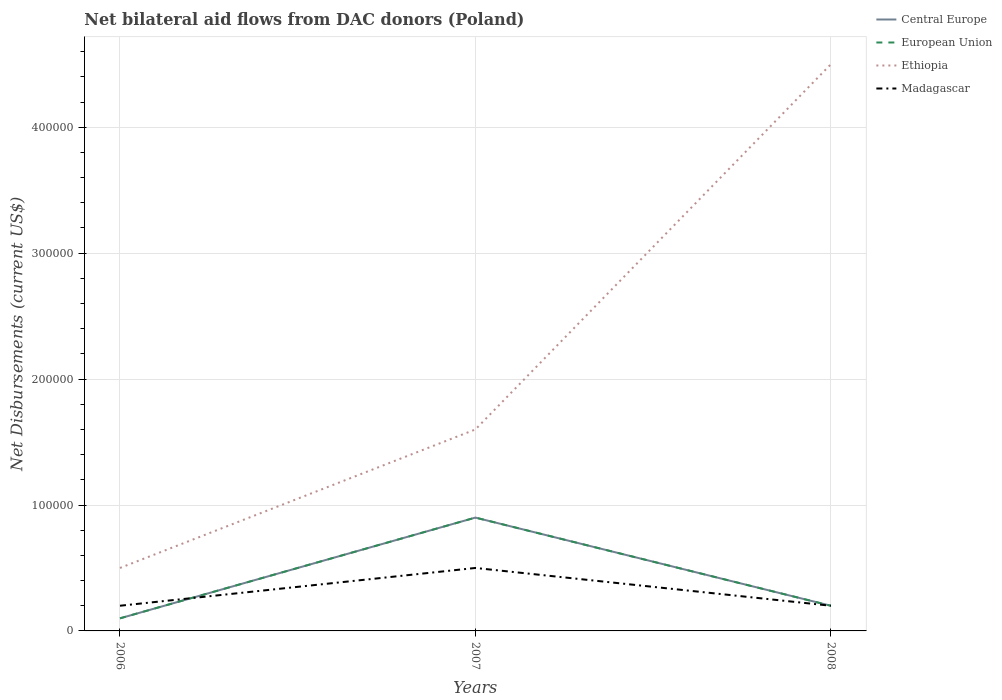How many different coloured lines are there?
Offer a very short reply. 4. Does the line corresponding to Madagascar intersect with the line corresponding to European Union?
Provide a short and direct response. Yes. Is the number of lines equal to the number of legend labels?
Your answer should be very brief. Yes. In which year was the net bilateral aid flows in European Union maximum?
Give a very brief answer. 2006. What is the total net bilateral aid flows in European Union in the graph?
Make the answer very short. -10000. What is the difference between the highest and the second highest net bilateral aid flows in Ethiopia?
Offer a terse response. 4.00e+05. What is the difference between the highest and the lowest net bilateral aid flows in Central Europe?
Offer a terse response. 1. Are the values on the major ticks of Y-axis written in scientific E-notation?
Provide a succinct answer. No. Where does the legend appear in the graph?
Ensure brevity in your answer.  Top right. How many legend labels are there?
Provide a short and direct response. 4. How are the legend labels stacked?
Your response must be concise. Vertical. What is the title of the graph?
Provide a succinct answer. Net bilateral aid flows from DAC donors (Poland). Does "Bermuda" appear as one of the legend labels in the graph?
Your answer should be compact. No. What is the label or title of the X-axis?
Your answer should be compact. Years. What is the label or title of the Y-axis?
Your answer should be very brief. Net Disbursements (current US$). What is the Net Disbursements (current US$) in European Union in 2006?
Offer a very short reply. 10000. What is the Net Disbursements (current US$) in Ethiopia in 2006?
Offer a terse response. 5.00e+04. What is the Net Disbursements (current US$) of Madagascar in 2006?
Offer a terse response. 2.00e+04. What is the Net Disbursements (current US$) in Central Europe in 2007?
Your response must be concise. 9.00e+04. What is the Net Disbursements (current US$) of Ethiopia in 2008?
Offer a terse response. 4.50e+05. What is the Net Disbursements (current US$) in Madagascar in 2008?
Ensure brevity in your answer.  2.00e+04. Across all years, what is the maximum Net Disbursements (current US$) of European Union?
Keep it short and to the point. 9.00e+04. Across all years, what is the maximum Net Disbursements (current US$) in Ethiopia?
Offer a terse response. 4.50e+05. Across all years, what is the maximum Net Disbursements (current US$) in Madagascar?
Ensure brevity in your answer.  5.00e+04. Across all years, what is the minimum Net Disbursements (current US$) in Central Europe?
Ensure brevity in your answer.  10000. What is the total Net Disbursements (current US$) in Central Europe in the graph?
Offer a terse response. 1.20e+05. What is the total Net Disbursements (current US$) of Ethiopia in the graph?
Your answer should be very brief. 6.60e+05. What is the total Net Disbursements (current US$) of Madagascar in the graph?
Provide a short and direct response. 9.00e+04. What is the difference between the Net Disbursements (current US$) in Central Europe in 2006 and that in 2007?
Give a very brief answer. -8.00e+04. What is the difference between the Net Disbursements (current US$) of European Union in 2006 and that in 2007?
Offer a terse response. -8.00e+04. What is the difference between the Net Disbursements (current US$) in Madagascar in 2006 and that in 2007?
Offer a very short reply. -3.00e+04. What is the difference between the Net Disbursements (current US$) of Central Europe in 2006 and that in 2008?
Offer a terse response. -10000. What is the difference between the Net Disbursements (current US$) in Ethiopia in 2006 and that in 2008?
Ensure brevity in your answer.  -4.00e+05. What is the difference between the Net Disbursements (current US$) of Madagascar in 2006 and that in 2008?
Offer a terse response. 0. What is the difference between the Net Disbursements (current US$) in Central Europe in 2007 and that in 2008?
Your answer should be compact. 7.00e+04. What is the difference between the Net Disbursements (current US$) of Ethiopia in 2007 and that in 2008?
Provide a short and direct response. -2.90e+05. What is the difference between the Net Disbursements (current US$) in Central Europe in 2006 and the Net Disbursements (current US$) in European Union in 2007?
Provide a short and direct response. -8.00e+04. What is the difference between the Net Disbursements (current US$) of Central Europe in 2006 and the Net Disbursements (current US$) of Ethiopia in 2007?
Your answer should be compact. -1.50e+05. What is the difference between the Net Disbursements (current US$) of Central Europe in 2006 and the Net Disbursements (current US$) of Madagascar in 2007?
Provide a succinct answer. -4.00e+04. What is the difference between the Net Disbursements (current US$) of European Union in 2006 and the Net Disbursements (current US$) of Madagascar in 2007?
Keep it short and to the point. -4.00e+04. What is the difference between the Net Disbursements (current US$) of Ethiopia in 2006 and the Net Disbursements (current US$) of Madagascar in 2007?
Make the answer very short. 0. What is the difference between the Net Disbursements (current US$) in Central Europe in 2006 and the Net Disbursements (current US$) in European Union in 2008?
Make the answer very short. -10000. What is the difference between the Net Disbursements (current US$) in Central Europe in 2006 and the Net Disbursements (current US$) in Ethiopia in 2008?
Your answer should be compact. -4.40e+05. What is the difference between the Net Disbursements (current US$) of European Union in 2006 and the Net Disbursements (current US$) of Ethiopia in 2008?
Your answer should be compact. -4.40e+05. What is the difference between the Net Disbursements (current US$) in European Union in 2006 and the Net Disbursements (current US$) in Madagascar in 2008?
Offer a very short reply. -10000. What is the difference between the Net Disbursements (current US$) of Central Europe in 2007 and the Net Disbursements (current US$) of Ethiopia in 2008?
Your response must be concise. -3.60e+05. What is the difference between the Net Disbursements (current US$) of European Union in 2007 and the Net Disbursements (current US$) of Ethiopia in 2008?
Your answer should be compact. -3.60e+05. What is the average Net Disbursements (current US$) of European Union per year?
Ensure brevity in your answer.  4.00e+04. What is the average Net Disbursements (current US$) of Ethiopia per year?
Make the answer very short. 2.20e+05. What is the average Net Disbursements (current US$) in Madagascar per year?
Ensure brevity in your answer.  3.00e+04. In the year 2006, what is the difference between the Net Disbursements (current US$) in Central Europe and Net Disbursements (current US$) in Ethiopia?
Keep it short and to the point. -4.00e+04. In the year 2006, what is the difference between the Net Disbursements (current US$) in Central Europe and Net Disbursements (current US$) in Madagascar?
Make the answer very short. -10000. In the year 2006, what is the difference between the Net Disbursements (current US$) of European Union and Net Disbursements (current US$) of Ethiopia?
Offer a terse response. -4.00e+04. In the year 2006, what is the difference between the Net Disbursements (current US$) in European Union and Net Disbursements (current US$) in Madagascar?
Keep it short and to the point. -10000. In the year 2006, what is the difference between the Net Disbursements (current US$) of Ethiopia and Net Disbursements (current US$) of Madagascar?
Offer a terse response. 3.00e+04. In the year 2007, what is the difference between the Net Disbursements (current US$) in Central Europe and Net Disbursements (current US$) in Madagascar?
Provide a succinct answer. 4.00e+04. In the year 2007, what is the difference between the Net Disbursements (current US$) in Ethiopia and Net Disbursements (current US$) in Madagascar?
Make the answer very short. 1.10e+05. In the year 2008, what is the difference between the Net Disbursements (current US$) in Central Europe and Net Disbursements (current US$) in European Union?
Offer a terse response. 0. In the year 2008, what is the difference between the Net Disbursements (current US$) in Central Europe and Net Disbursements (current US$) in Ethiopia?
Make the answer very short. -4.30e+05. In the year 2008, what is the difference between the Net Disbursements (current US$) of Central Europe and Net Disbursements (current US$) of Madagascar?
Keep it short and to the point. 0. In the year 2008, what is the difference between the Net Disbursements (current US$) of European Union and Net Disbursements (current US$) of Ethiopia?
Offer a terse response. -4.30e+05. In the year 2008, what is the difference between the Net Disbursements (current US$) of European Union and Net Disbursements (current US$) of Madagascar?
Provide a succinct answer. 0. In the year 2008, what is the difference between the Net Disbursements (current US$) in Ethiopia and Net Disbursements (current US$) in Madagascar?
Your answer should be very brief. 4.30e+05. What is the ratio of the Net Disbursements (current US$) in Central Europe in 2006 to that in 2007?
Make the answer very short. 0.11. What is the ratio of the Net Disbursements (current US$) in European Union in 2006 to that in 2007?
Your answer should be compact. 0.11. What is the ratio of the Net Disbursements (current US$) of Ethiopia in 2006 to that in 2007?
Give a very brief answer. 0.31. What is the ratio of the Net Disbursements (current US$) of Madagascar in 2006 to that in 2007?
Ensure brevity in your answer.  0.4. What is the ratio of the Net Disbursements (current US$) of Central Europe in 2006 to that in 2008?
Your response must be concise. 0.5. What is the ratio of the Net Disbursements (current US$) of Ethiopia in 2007 to that in 2008?
Your answer should be compact. 0.36. What is the difference between the highest and the second highest Net Disbursements (current US$) in Central Europe?
Offer a very short reply. 7.00e+04. What is the difference between the highest and the second highest Net Disbursements (current US$) in European Union?
Offer a very short reply. 7.00e+04. What is the difference between the highest and the second highest Net Disbursements (current US$) in Ethiopia?
Your answer should be very brief. 2.90e+05. What is the difference between the highest and the lowest Net Disbursements (current US$) of Central Europe?
Make the answer very short. 8.00e+04. What is the difference between the highest and the lowest Net Disbursements (current US$) in Madagascar?
Your answer should be very brief. 3.00e+04. 